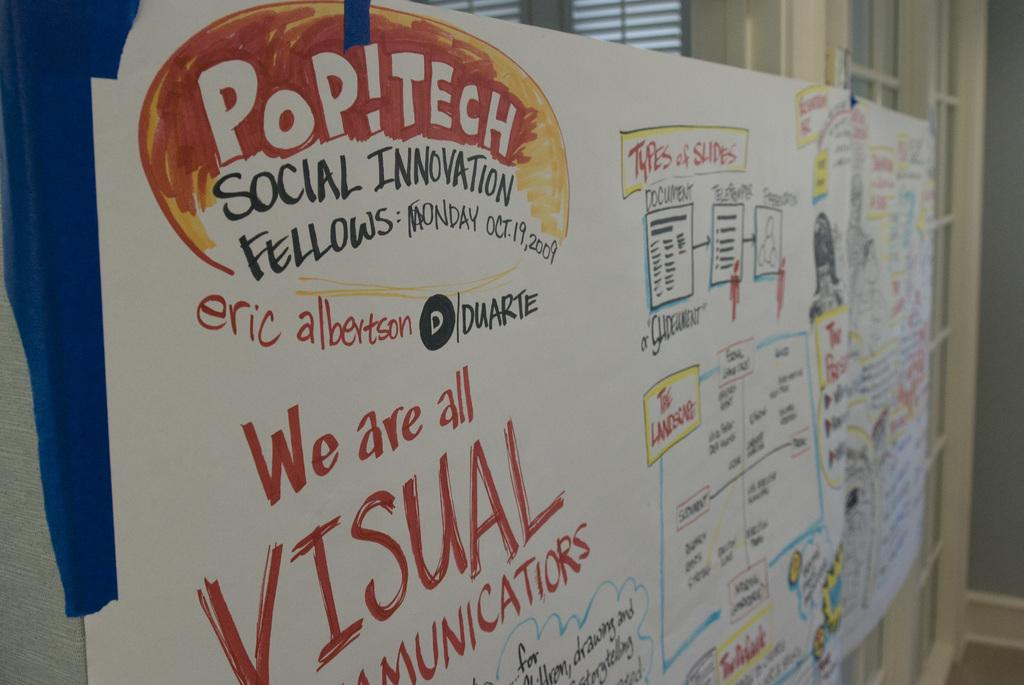<image>
Write a terse but informative summary of the picture. A large white board featuring Pop!Tech Social Innovation Fellows. 